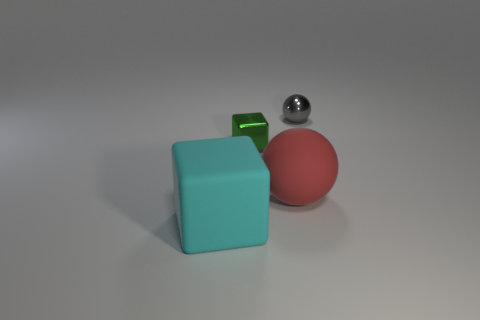Add 3 small purple rubber balls. How many objects exist? 7 Add 3 gray metal things. How many gray metal things exist? 4 Subtract 0 red cylinders. How many objects are left? 4 Subtract all tiny things. Subtract all cyan matte things. How many objects are left? 1 Add 2 big matte blocks. How many big matte blocks are left? 3 